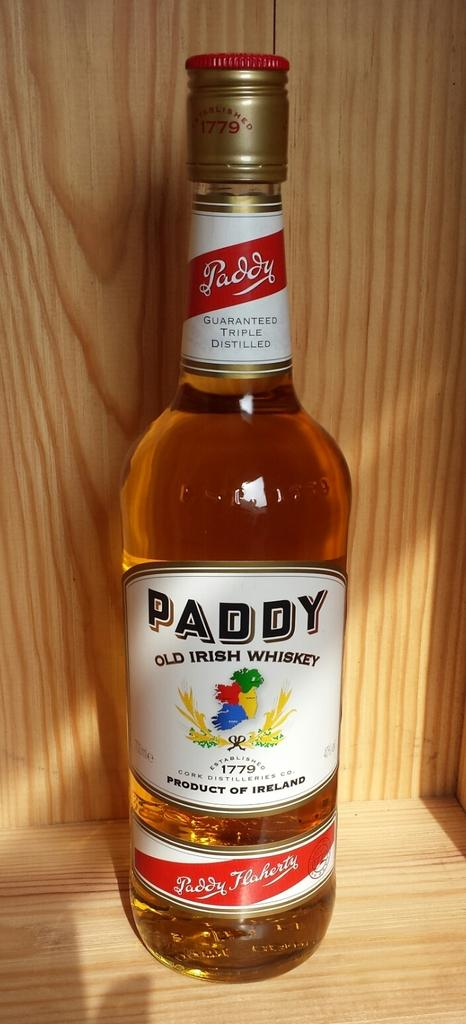What object can be seen in the image? There is a bottle in the image. What is written on the bottle? The word "paddy" is written on the bottle. Can you see a volleyball being played in the image? No, there is no volleyball or any indication of a game being played in the image. Are there any owls visible in the image? No, there are no owls present in the image. 